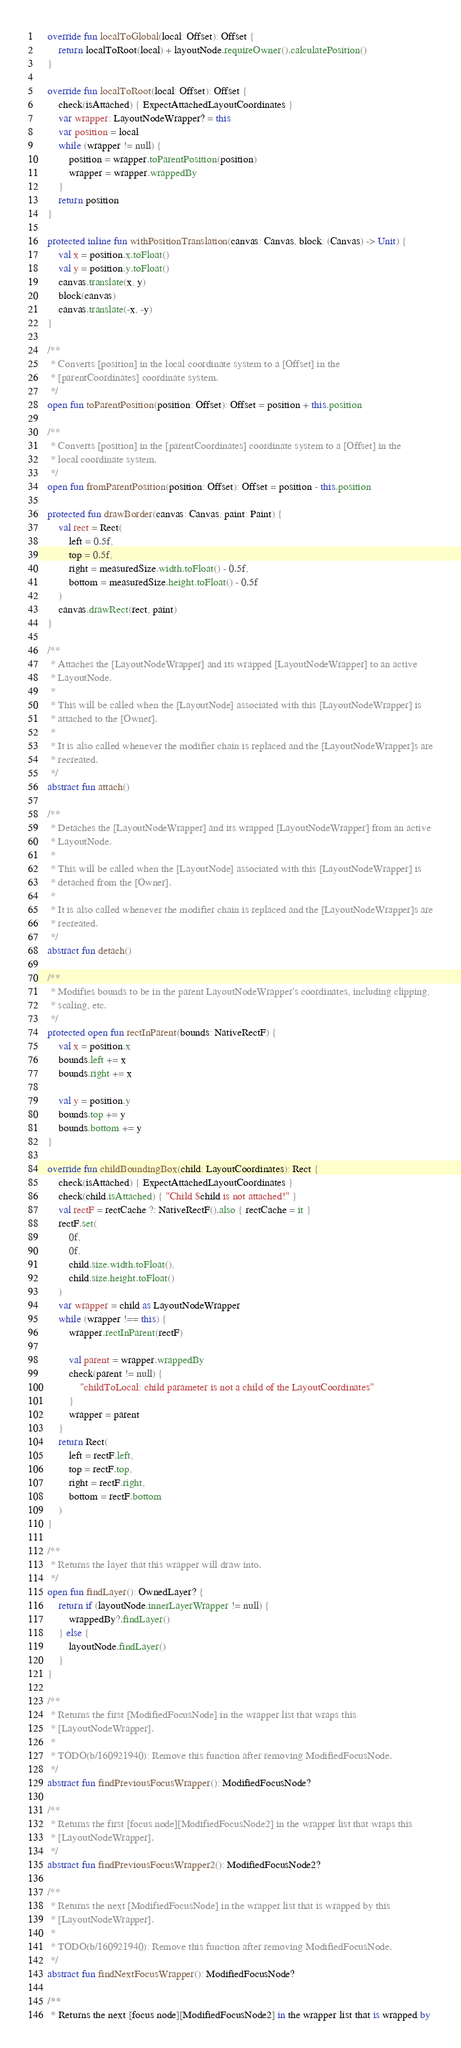<code> <loc_0><loc_0><loc_500><loc_500><_Kotlin_>
    override fun localToGlobal(local: Offset): Offset {
        return localToRoot(local) + layoutNode.requireOwner().calculatePosition()
    }

    override fun localToRoot(local: Offset): Offset {
        check(isAttached) { ExpectAttachedLayoutCoordinates }
        var wrapper: LayoutNodeWrapper? = this
        var position = local
        while (wrapper != null) {
            position = wrapper.toParentPosition(position)
            wrapper = wrapper.wrappedBy
        }
        return position
    }

    protected inline fun withPositionTranslation(canvas: Canvas, block: (Canvas) -> Unit) {
        val x = position.x.toFloat()
        val y = position.y.toFloat()
        canvas.translate(x, y)
        block(canvas)
        canvas.translate(-x, -y)
    }

    /**
     * Converts [position] in the local coordinate system to a [Offset] in the
     * [parentCoordinates] coordinate system.
     */
    open fun toParentPosition(position: Offset): Offset = position + this.position

    /**
     * Converts [position] in the [parentCoordinates] coordinate system to a [Offset] in the
     * local coordinate system.
     */
    open fun fromParentPosition(position: Offset): Offset = position - this.position

    protected fun drawBorder(canvas: Canvas, paint: Paint) {
        val rect = Rect(
            left = 0.5f,
            top = 0.5f,
            right = measuredSize.width.toFloat() - 0.5f,
            bottom = measuredSize.height.toFloat() - 0.5f
        )
        canvas.drawRect(rect, paint)
    }

    /**
     * Attaches the [LayoutNodeWrapper] and its wrapped [LayoutNodeWrapper] to an active
     * LayoutNode.
     *
     * This will be called when the [LayoutNode] associated with this [LayoutNodeWrapper] is
     * attached to the [Owner].
     *
     * It is also called whenever the modifier chain is replaced and the [LayoutNodeWrapper]s are
     * recreated.
     */
    abstract fun attach()

    /**
     * Detaches the [LayoutNodeWrapper] and its wrapped [LayoutNodeWrapper] from an active
     * LayoutNode.
     *
     * This will be called when the [LayoutNode] associated with this [LayoutNodeWrapper] is
     * detached from the [Owner].
     *
     * It is also called whenever the modifier chain is replaced and the [LayoutNodeWrapper]s are
     * recreated.
     */
    abstract fun detach()

    /**
     * Modifies bounds to be in the parent LayoutNodeWrapper's coordinates, including clipping,
     * scaling, etc.
     */
    protected open fun rectInParent(bounds: NativeRectF) {
        val x = position.x
        bounds.left += x
        bounds.right += x

        val y = position.y
        bounds.top += y
        bounds.bottom += y
    }

    override fun childBoundingBox(child: LayoutCoordinates): Rect {
        check(isAttached) { ExpectAttachedLayoutCoordinates }
        check(child.isAttached) { "Child $child is not attached!" }
        val rectF = rectCache ?: NativeRectF().also { rectCache = it }
        rectF.set(
            0f,
            0f,
            child.size.width.toFloat(),
            child.size.height.toFloat()
        )
        var wrapper = child as LayoutNodeWrapper
        while (wrapper !== this) {
            wrapper.rectInParent(rectF)

            val parent = wrapper.wrappedBy
            check(parent != null) {
                "childToLocal: child parameter is not a child of the LayoutCoordinates"
            }
            wrapper = parent
        }
        return Rect(
            left = rectF.left,
            top = rectF.top,
            right = rectF.right,
            bottom = rectF.bottom
        )
    }

    /**
     * Returns the layer that this wrapper will draw into.
     */
    open fun findLayer(): OwnedLayer? {
        return if (layoutNode.innerLayerWrapper != null) {
            wrappedBy?.findLayer()
        } else {
            layoutNode.findLayer()
        }
    }

    /**
     * Returns the first [ModifiedFocusNode] in the wrapper list that wraps this
     * [LayoutNodeWrapper].
     *
     * TODO(b/160921940): Remove this function after removing ModifiedFocusNode.
     */
    abstract fun findPreviousFocusWrapper(): ModifiedFocusNode?

    /**
     * Returns the first [focus node][ModifiedFocusNode2] in the wrapper list that wraps this
     * [LayoutNodeWrapper].
     */
    abstract fun findPreviousFocusWrapper2(): ModifiedFocusNode2?

    /**
     * Returns the next [ModifiedFocusNode] in the wrapper list that is wrapped by this
     * [LayoutNodeWrapper].
     *
     * TODO(b/160921940): Remove this function after removing ModifiedFocusNode.
     */
    abstract fun findNextFocusWrapper(): ModifiedFocusNode?

    /**
     * Returns the next [focus node][ModifiedFocusNode2] in the wrapper list that is wrapped by</code> 